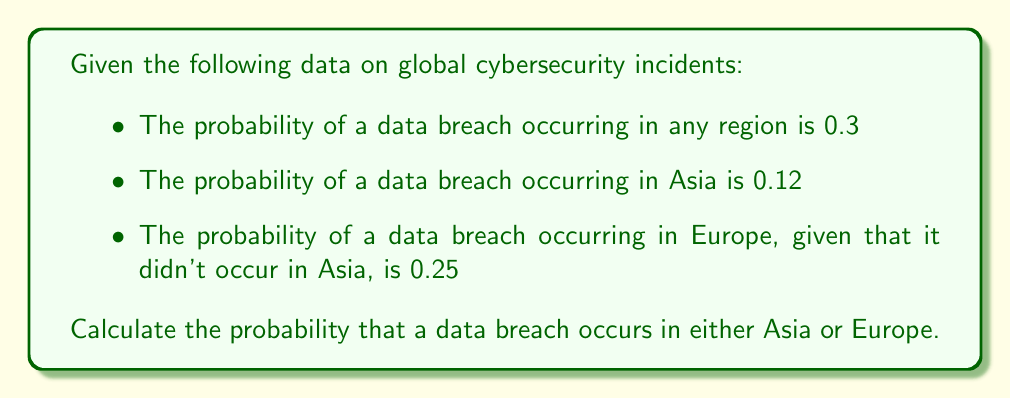Show me your answer to this math problem. Let's approach this step-by-step using conditional probability:

1) Let A be the event of a data breach occurring in Asia
   Let E be the event of a data breach occurring in Europe

2) We're given:
   $P(A) = 0.12$
   $P(E|A^c) = 0.25$ (probability of E given that A did not occur)
   
3) We need to find $P(A \cup E)$ (probability of A or E)

4) We can use the addition rule of probability:
   $P(A \cup E) = P(A) + P(E) - P(A \cap E)$

5) We know $P(A)$, but we need to find $P(E)$ and $P(A \cap E)$

6) To find $P(E)$, we can use the law of total probability:
   $P(E) = P(E|A)P(A) + P(E|A^c)P(A^c)$

7) We know $P(E|A^c)$ and $P(A)$, so we can find $P(A^c)$:
   $P(A^c) = 1 - P(A) = 1 - 0.12 = 0.88$

8) We don't know $P(E|A)$, but we can assume independence between regions:
   $P(E|A) = P(E|A^c) = 0.25$

9) Now we can calculate $P(E)$:
   $P(E) = 0.25 * 0.12 + 0.25 * 0.88 = 0.25$

10) For $P(A \cap E)$, assuming independence:
    $P(A \cap E) = P(A) * P(E) = 0.12 * 0.25 = 0.03$

11) Finally, we can calculate $P(A \cup E)$:
    $P(A \cup E) = P(A) + P(E) - P(A \cap E)$
    $P(A \cup E) = 0.12 + 0.25 - 0.03 = 0.34$

Therefore, the probability of a data breach occurring in either Asia or Europe is 0.34 or 34%.
Answer: 0.34 